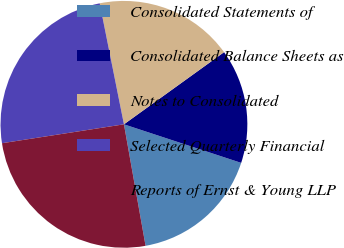Convert chart. <chart><loc_0><loc_0><loc_500><loc_500><pie_chart><fcel>Consolidated Statements of<fcel>Consolidated Balance Sheets as<fcel>Notes to Consolidated<fcel>Selected Quarterly Financial<fcel>Reports of Ernst & Young LLP<nl><fcel>17.14%<fcel>15.0%<fcel>18.21%<fcel>24.3%<fcel>25.36%<nl></chart> 